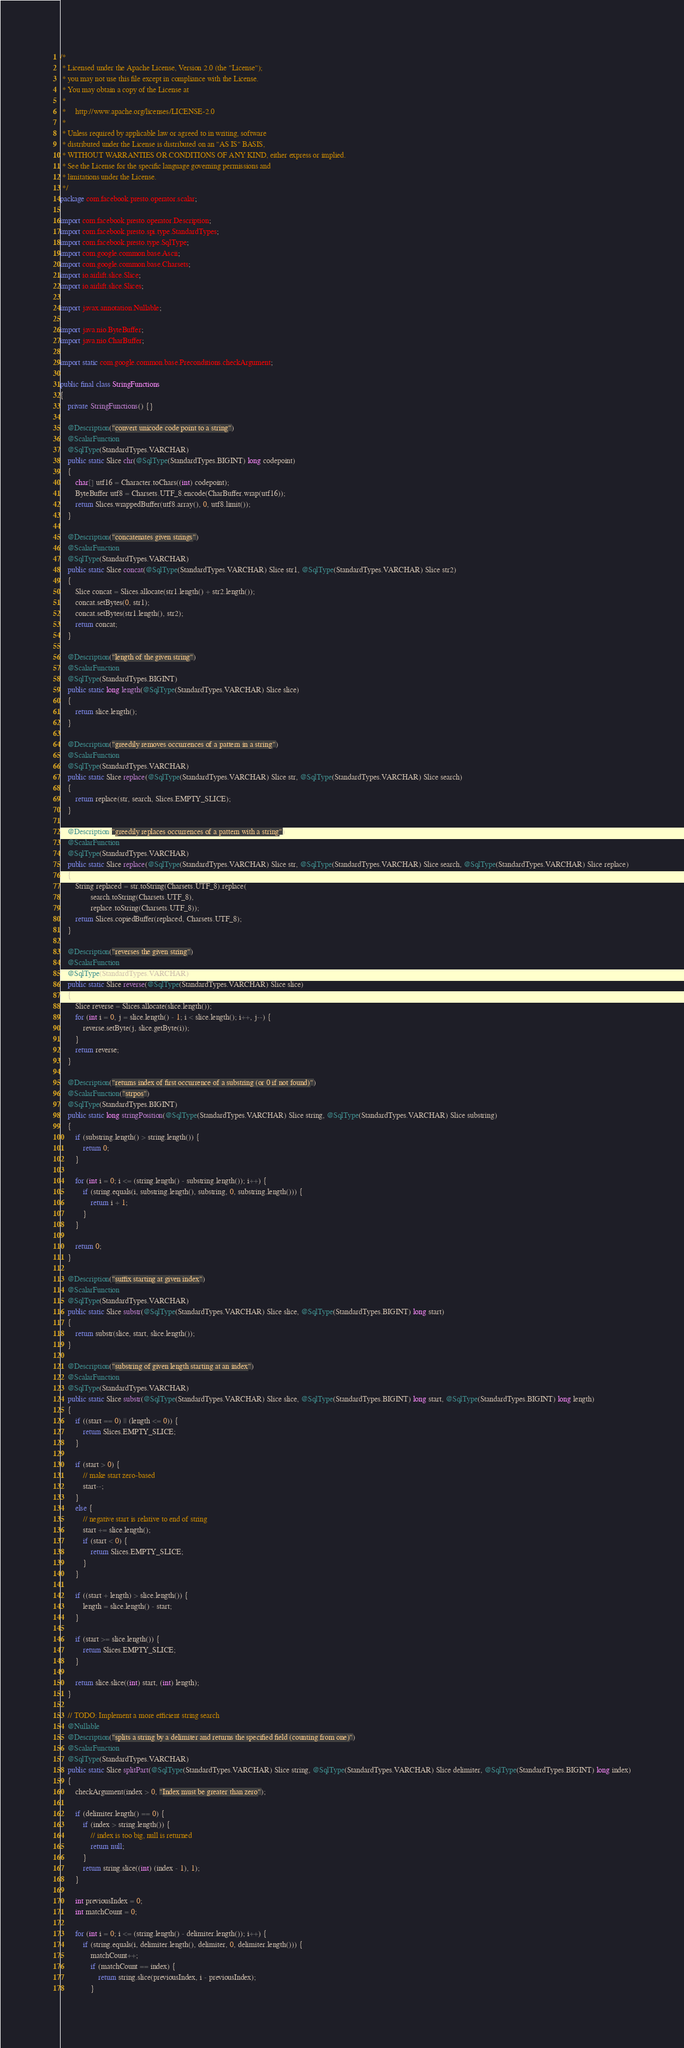<code> <loc_0><loc_0><loc_500><loc_500><_Java_>/*
 * Licensed under the Apache License, Version 2.0 (the "License");
 * you may not use this file except in compliance with the License.
 * You may obtain a copy of the License at
 *
 *     http://www.apache.org/licenses/LICENSE-2.0
 *
 * Unless required by applicable law or agreed to in writing, software
 * distributed under the License is distributed on an "AS IS" BASIS,
 * WITHOUT WARRANTIES OR CONDITIONS OF ANY KIND, either express or implied.
 * See the License for the specific language governing permissions and
 * limitations under the License.
 */
package com.facebook.presto.operator.scalar;

import com.facebook.presto.operator.Description;
import com.facebook.presto.spi.type.StandardTypes;
import com.facebook.presto.type.SqlType;
import com.google.common.base.Ascii;
import com.google.common.base.Charsets;
import io.airlift.slice.Slice;
import io.airlift.slice.Slices;

import javax.annotation.Nullable;

import java.nio.ByteBuffer;
import java.nio.CharBuffer;

import static com.google.common.base.Preconditions.checkArgument;

public final class StringFunctions
{
    private StringFunctions() {}

    @Description("convert unicode code point to a string")
    @ScalarFunction
    @SqlType(StandardTypes.VARCHAR)
    public static Slice chr(@SqlType(StandardTypes.BIGINT) long codepoint)
    {
        char[] utf16 = Character.toChars((int) codepoint);
        ByteBuffer utf8 = Charsets.UTF_8.encode(CharBuffer.wrap(utf16));
        return Slices.wrappedBuffer(utf8.array(), 0, utf8.limit());
    }

    @Description("concatenates given strings")
    @ScalarFunction
    @SqlType(StandardTypes.VARCHAR)
    public static Slice concat(@SqlType(StandardTypes.VARCHAR) Slice str1, @SqlType(StandardTypes.VARCHAR) Slice str2)
    {
        Slice concat = Slices.allocate(str1.length() + str2.length());
        concat.setBytes(0, str1);
        concat.setBytes(str1.length(), str2);
        return concat;
    }

    @Description("length of the given string")
    @ScalarFunction
    @SqlType(StandardTypes.BIGINT)
    public static long length(@SqlType(StandardTypes.VARCHAR) Slice slice)
    {
        return slice.length();
    }

    @Description("greedily removes occurrences of a pattern in a string")
    @ScalarFunction
    @SqlType(StandardTypes.VARCHAR)
    public static Slice replace(@SqlType(StandardTypes.VARCHAR) Slice str, @SqlType(StandardTypes.VARCHAR) Slice search)
    {
        return replace(str, search, Slices.EMPTY_SLICE);
    }

    @Description("greedily replaces occurrences of a pattern with a string")
    @ScalarFunction
    @SqlType(StandardTypes.VARCHAR)
    public static Slice replace(@SqlType(StandardTypes.VARCHAR) Slice str, @SqlType(StandardTypes.VARCHAR) Slice search, @SqlType(StandardTypes.VARCHAR) Slice replace)
    {
        String replaced = str.toString(Charsets.UTF_8).replace(
                search.toString(Charsets.UTF_8),
                replace.toString(Charsets.UTF_8));
        return Slices.copiedBuffer(replaced, Charsets.UTF_8);
    }

    @Description("reverses the given string")
    @ScalarFunction
    @SqlType(StandardTypes.VARCHAR)
    public static Slice reverse(@SqlType(StandardTypes.VARCHAR) Slice slice)
    {
        Slice reverse = Slices.allocate(slice.length());
        for (int i = 0, j = slice.length() - 1; i < slice.length(); i++, j--) {
            reverse.setByte(j, slice.getByte(i));
        }
        return reverse;
    }

    @Description("returns index of first occurrence of a substring (or 0 if not found)")
    @ScalarFunction("strpos")
    @SqlType(StandardTypes.BIGINT)
    public static long stringPosition(@SqlType(StandardTypes.VARCHAR) Slice string, @SqlType(StandardTypes.VARCHAR) Slice substring)
    {
        if (substring.length() > string.length()) {
            return 0;
        }

        for (int i = 0; i <= (string.length() - substring.length()); i++) {
            if (string.equals(i, substring.length(), substring, 0, substring.length())) {
                return i + 1;
            }
        }

        return 0;
    }

    @Description("suffix starting at given index")
    @ScalarFunction
    @SqlType(StandardTypes.VARCHAR)
    public static Slice substr(@SqlType(StandardTypes.VARCHAR) Slice slice, @SqlType(StandardTypes.BIGINT) long start)
    {
        return substr(slice, start, slice.length());
    }

    @Description("substring of given length starting at an index")
    @ScalarFunction
    @SqlType(StandardTypes.VARCHAR)
    public static Slice substr(@SqlType(StandardTypes.VARCHAR) Slice slice, @SqlType(StandardTypes.BIGINT) long start, @SqlType(StandardTypes.BIGINT) long length)
    {
        if ((start == 0) || (length <= 0)) {
            return Slices.EMPTY_SLICE;
        }

        if (start > 0) {
            // make start zero-based
            start--;
        }
        else {
            // negative start is relative to end of string
            start += slice.length();
            if (start < 0) {
                return Slices.EMPTY_SLICE;
            }
        }

        if ((start + length) > slice.length()) {
            length = slice.length() - start;
        }

        if (start >= slice.length()) {
            return Slices.EMPTY_SLICE;
        }

        return slice.slice((int) start, (int) length);
    }

    // TODO: Implement a more efficient string search
    @Nullable
    @Description("splits a string by a delimiter and returns the specified field (counting from one)")
    @ScalarFunction
    @SqlType(StandardTypes.VARCHAR)
    public static Slice splitPart(@SqlType(StandardTypes.VARCHAR) Slice string, @SqlType(StandardTypes.VARCHAR) Slice delimiter, @SqlType(StandardTypes.BIGINT) long index)
    {
        checkArgument(index > 0, "Index must be greater than zero");

        if (delimiter.length() == 0) {
            if (index > string.length()) {
                // index is too big, null is returned
                return null;
            }
            return string.slice((int) (index - 1), 1);
        }

        int previousIndex = 0;
        int matchCount = 0;

        for (int i = 0; i <= (string.length() - delimiter.length()); i++) {
            if (string.equals(i, delimiter.length(), delimiter, 0, delimiter.length())) {
                matchCount++;
                if (matchCount == index) {
                    return string.slice(previousIndex, i - previousIndex);
                }</code> 